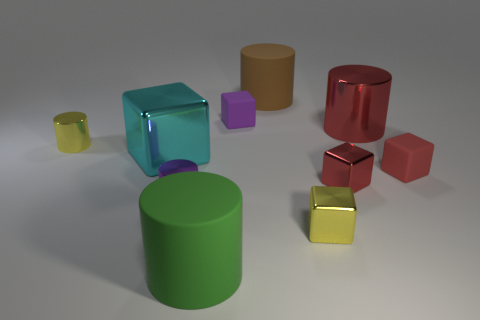Subtract all green cylinders. How many cylinders are left? 4 Subtract all small matte cubes. How many cubes are left? 3 Subtract 1 blocks. How many blocks are left? 4 Subtract all yellow cubes. Subtract all blue cylinders. How many cubes are left? 4 Subtract all brown cubes. How many green cylinders are left? 1 Subtract all purple blocks. Subtract all big cubes. How many objects are left? 8 Add 2 small yellow shiny cubes. How many small yellow shiny cubes are left? 3 Add 1 large green rubber cylinders. How many large green rubber cylinders exist? 2 Subtract 1 red cubes. How many objects are left? 9 